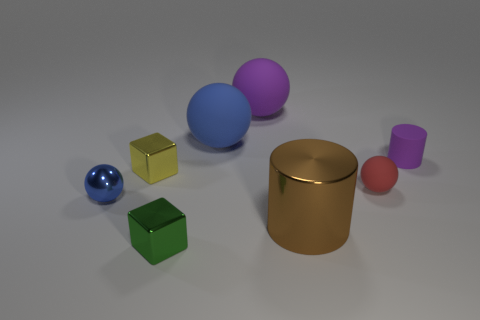Subtract all tiny blue balls. How many balls are left? 3 Subtract 1 cylinders. How many cylinders are left? 1 Add 1 large cyan matte blocks. How many objects exist? 9 Subtract all blue spheres. How many spheres are left? 2 Subtract all blocks. How many objects are left? 6 Subtract all blue cylinders. Subtract all cyan blocks. How many cylinders are left? 2 Subtract all blue cylinders. How many brown cubes are left? 0 Subtract all large brown shiny objects. Subtract all big balls. How many objects are left? 5 Add 1 big metal things. How many big metal things are left? 2 Add 1 big purple rubber spheres. How many big purple rubber spheres exist? 2 